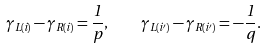<formula> <loc_0><loc_0><loc_500><loc_500>\gamma _ { L ( i ) } - \gamma _ { R ( i ) } = \frac { 1 } { p } , \quad \gamma _ { L ( i ^ { \prime } ) } - \gamma _ { R ( i ^ { \prime } ) } = - \frac { 1 } { q } .</formula> 